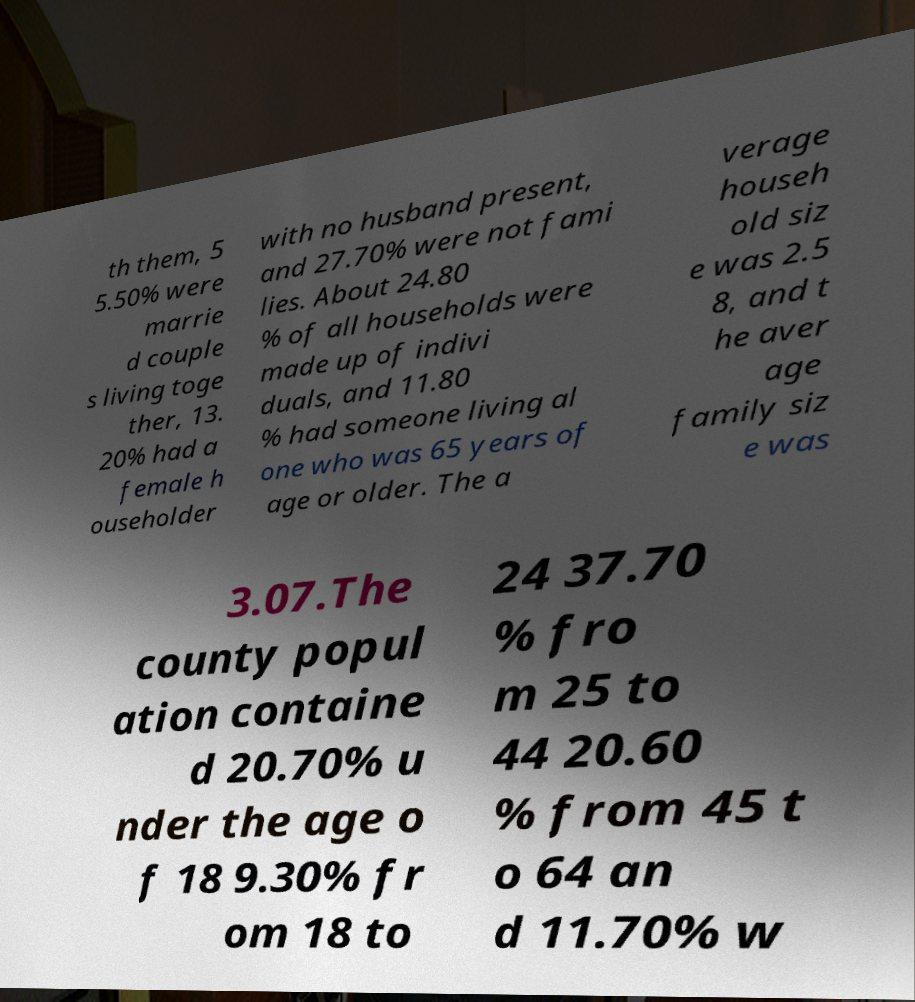I need the written content from this picture converted into text. Can you do that? th them, 5 5.50% were marrie d couple s living toge ther, 13. 20% had a female h ouseholder with no husband present, and 27.70% were not fami lies. About 24.80 % of all households were made up of indivi duals, and 11.80 % had someone living al one who was 65 years of age or older. The a verage househ old siz e was 2.5 8, and t he aver age family siz e was 3.07.The county popul ation containe d 20.70% u nder the age o f 18 9.30% fr om 18 to 24 37.70 % fro m 25 to 44 20.60 % from 45 t o 64 an d 11.70% w 